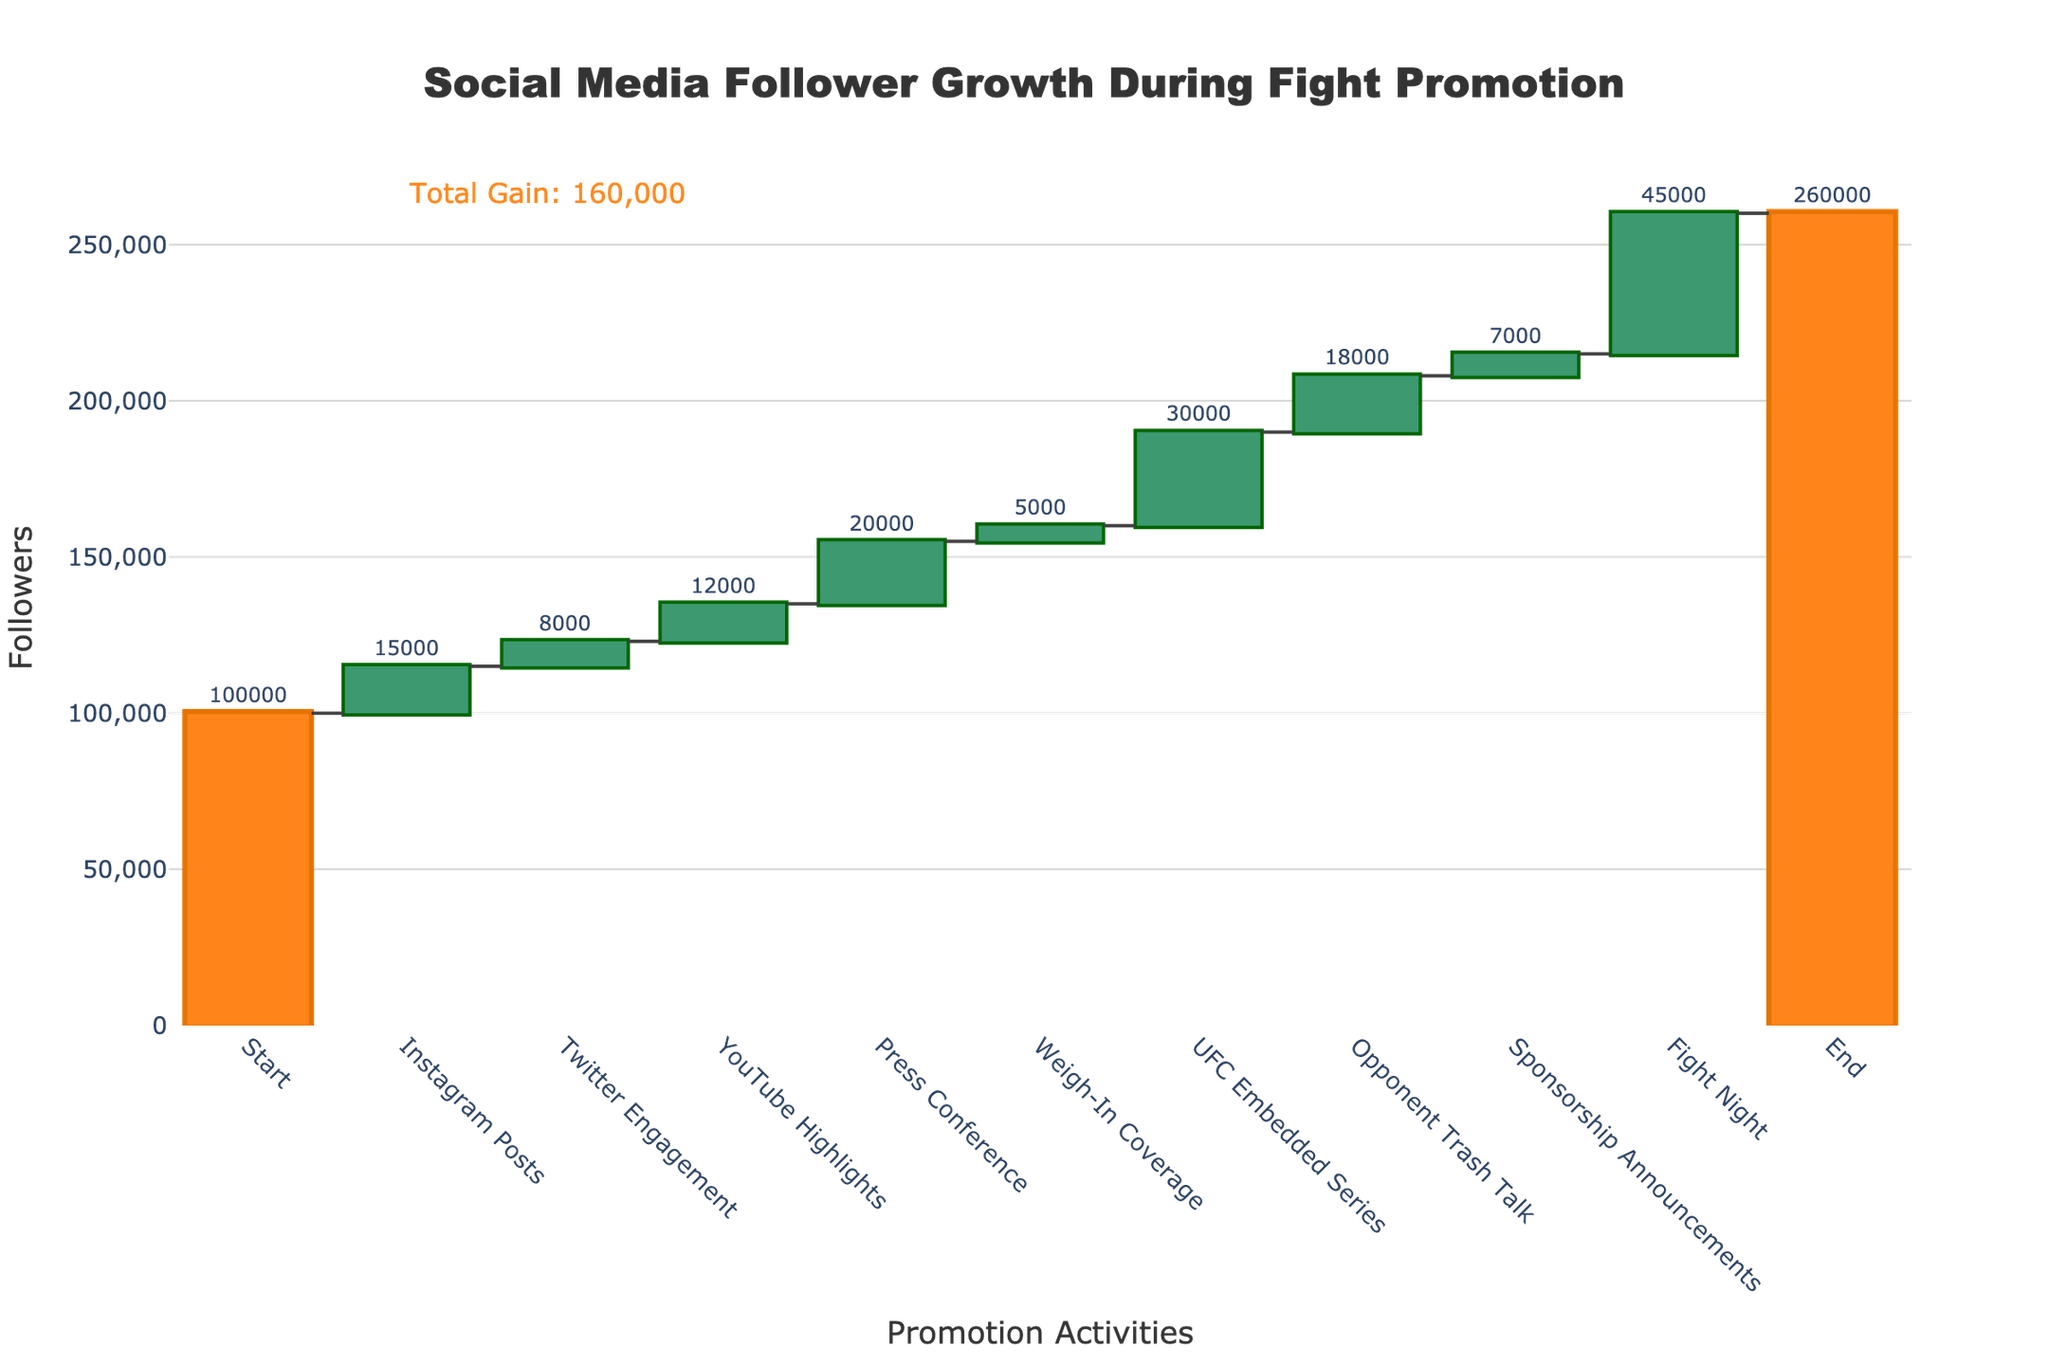What is the title of the chart? The title is located at the top of the figure and is clearly labeled for easy identification.
Answer: Social Media Follower Growth During Fight Promotion How many followers did you start with at the beginning of the promotion? The 'Start' category on the x-axis indicates the initial count of followers in the figure.
Answer: 100,000 Which promotional activity led to the highest gain in followers? By observing the heights of the bars in the waterfall chart, the activity with the tallest increasing bar represents the highest gain in followers.
Answer: Fight Night What is the total number of followers gained from the YouTube Highlights and Press Conference combined? Add the followers gained from both 'YouTube Highlights' and 'Press Conference' bars.
Answer: 12,000 + 20,000 = 32,000 What is the difference in follower gain between the Press Conference and the Weigh-In Coverage? Subtract the follower gain of the 'Weigh-In Coverage' from the 'Press Conference'.
Answer: 20,000 - 5,000 = 15,000 How many promotional activities resulted in an increase in followers? Count the number of bars in the increasing color throughout the chart.
Answer: 8 What is the final number of followers at the end of the promotion period? The 'End' category on the x-axis shows the final count of followers in the figure.
Answer: 260,000 Which promotional activity had the smallest impact on follower gain, excluding the start and end? The bar with the smallest height among promotional activities (excluding the initial and final values) represents the smallest impact.
Answer: Weigh-In Coverage How does the gain from Opponent Trash Talk compare to the gain from Sponsorship Announcements? Compare the heights of the 'Opponent Trash Talk' and 'Sponsorship Announcements' bars to determine which is larger.
Answer: Opponent Trash Talk had a higher gain What is the total number of followers gained throughout the promotional period? Subtract the initial followers at 'Start' from the followers at 'End' to get the total gain.
Answer: 260,000 - 100,000 = 160,000 